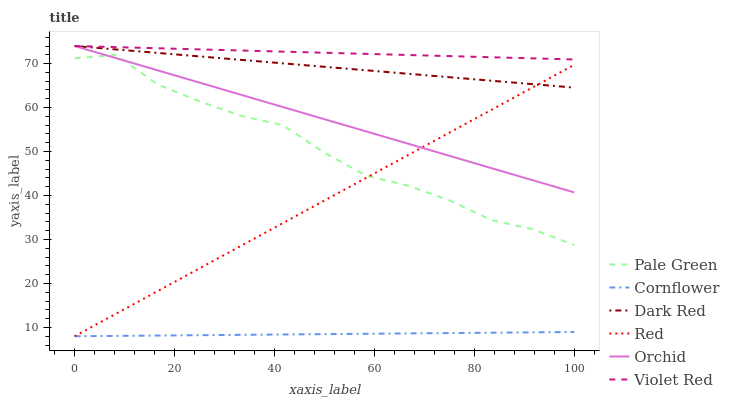Does Cornflower have the minimum area under the curve?
Answer yes or no. Yes. Does Violet Red have the maximum area under the curve?
Answer yes or no. Yes. Does Dark Red have the minimum area under the curve?
Answer yes or no. No. Does Dark Red have the maximum area under the curve?
Answer yes or no. No. Is Cornflower the smoothest?
Answer yes or no. Yes. Is Pale Green the roughest?
Answer yes or no. Yes. Is Violet Red the smoothest?
Answer yes or no. No. Is Violet Red the roughest?
Answer yes or no. No. Does Cornflower have the lowest value?
Answer yes or no. Yes. Does Dark Red have the lowest value?
Answer yes or no. No. Does Orchid have the highest value?
Answer yes or no. Yes. Does Pale Green have the highest value?
Answer yes or no. No. Is Cornflower less than Orchid?
Answer yes or no. Yes. Is Orchid greater than Cornflower?
Answer yes or no. Yes. Does Pale Green intersect Orchid?
Answer yes or no. Yes. Is Pale Green less than Orchid?
Answer yes or no. No. Is Pale Green greater than Orchid?
Answer yes or no. No. Does Cornflower intersect Orchid?
Answer yes or no. No. 